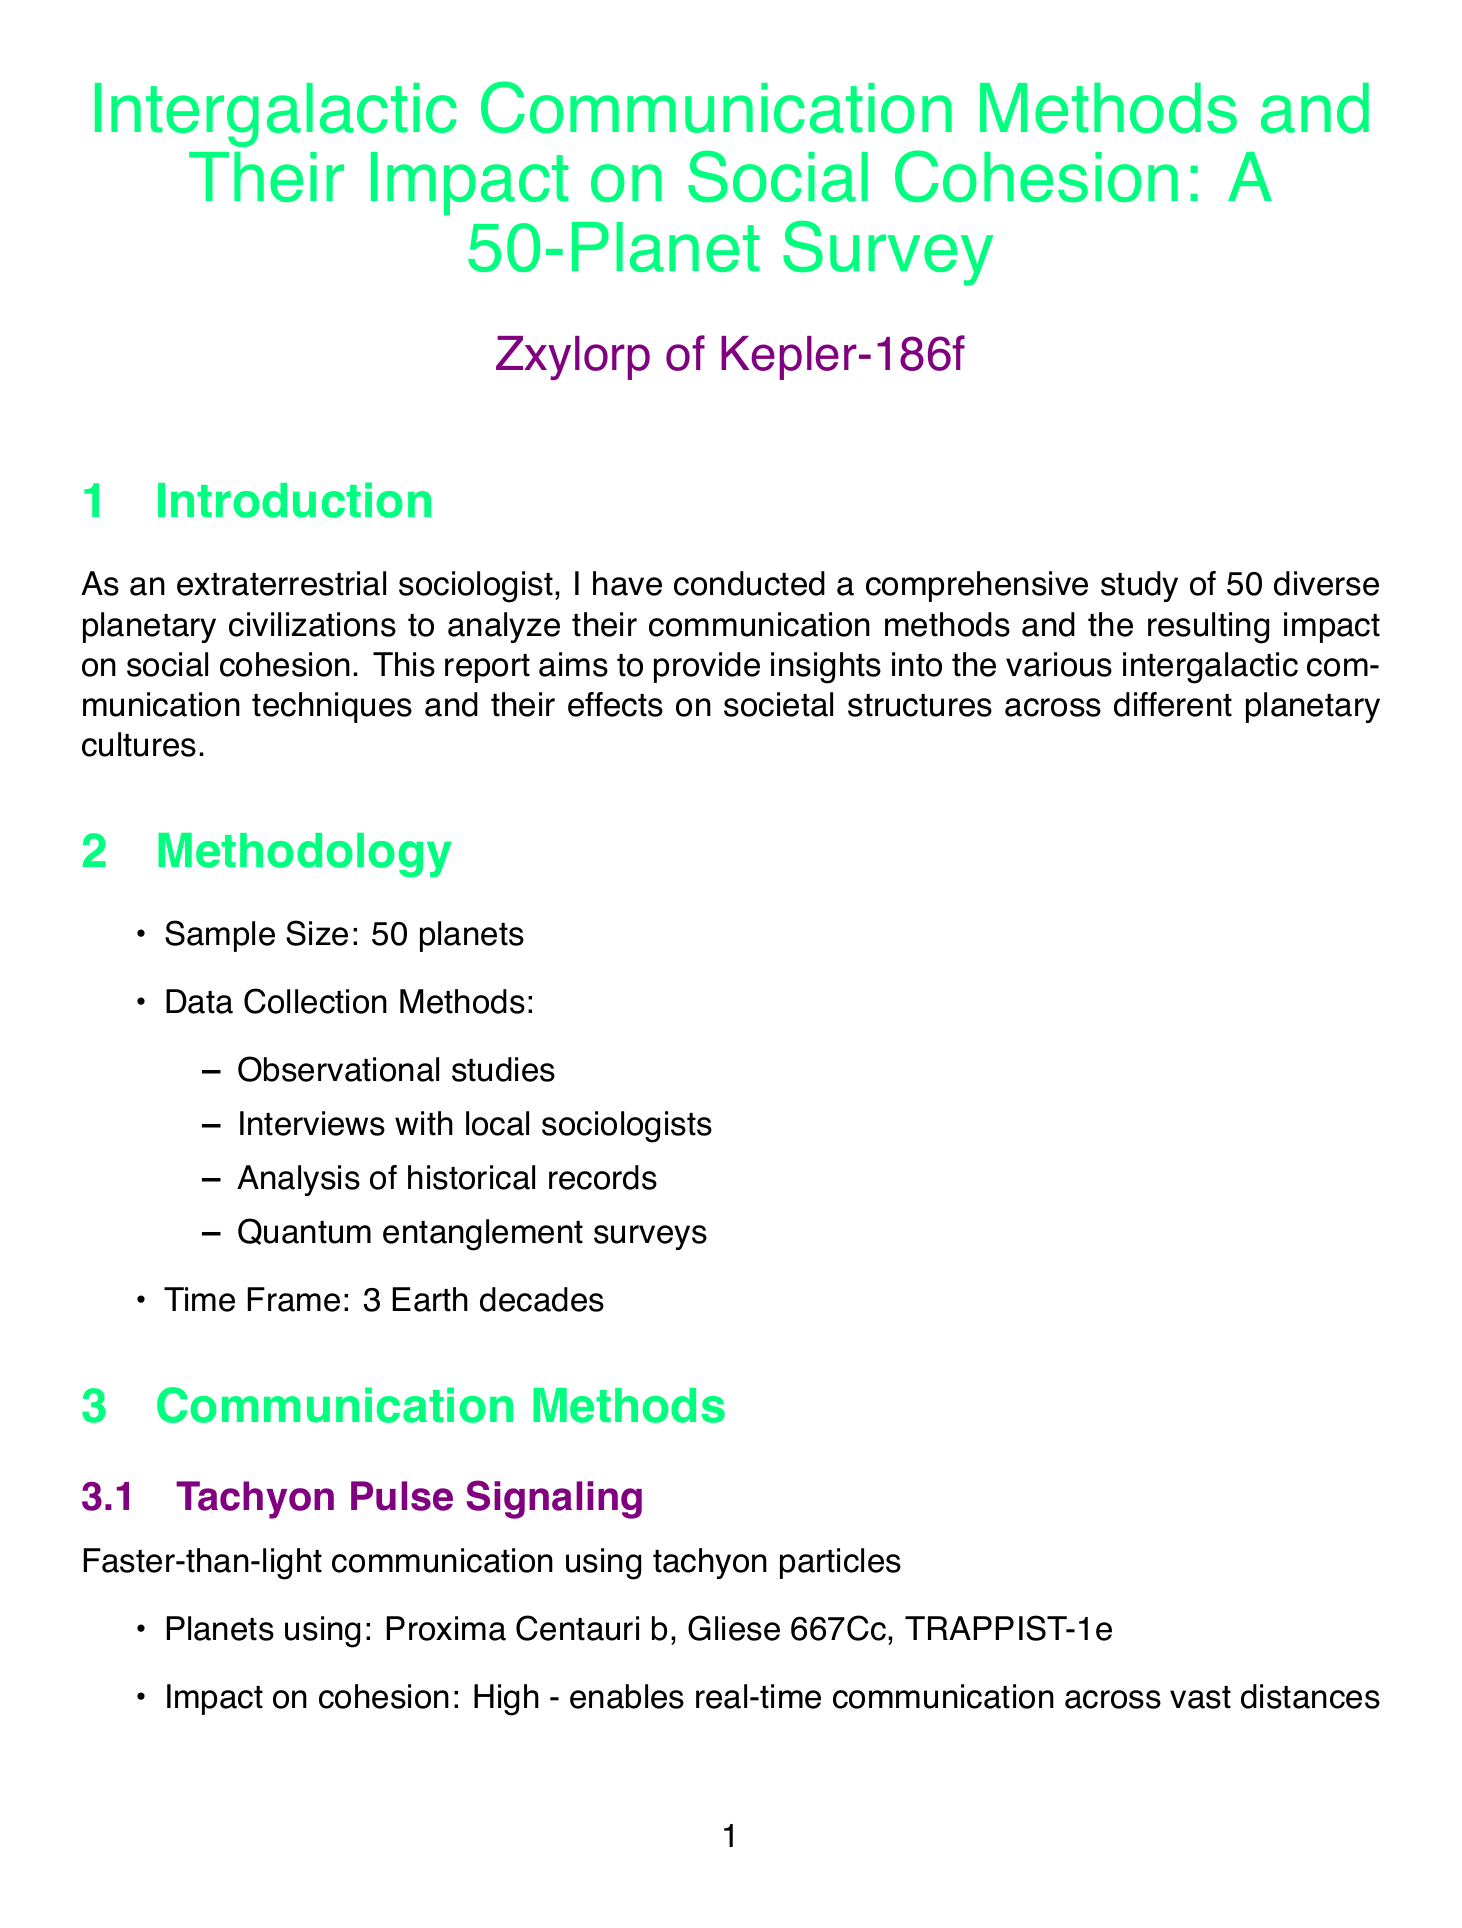what is the title of the report? The title is presented prominently at the beginning of the document.
Answer: Intergalactic Communication Methods and Their Impact on Social Cohesion: A 50-Planet Survey who is the author of the report? The author's name is provided in the author section of the document.
Answer: Zxylorp of Kepler-186f how many planets were included in the survey? The sample size is explicitly stated in the methodology section.
Answer: 50 which communication method is used by Proxima Centauri b? The planets using specific communication methods are listed in the communication methods section.
Answer: Tachyon Pulse Signaling what is the cohesion impact of Quantum Telepathy Networks? The impact on social cohesion is summarized in the description of each communication method.
Answer: Very high which social structure prefers Gravitational Wave Modulation? The communication preference for each social structure is detailed in the social structures section.
Answer: Distributed Democracies what is the cohesion level of Hive Mind Collectives? The cohesion level for each type of social structure is stated in the social structures section.
Answer: Extremely high which communication method is linked with Caste-based Hierarchies? The communication methods used by each social structure are specified in the document.
Answer: Bioluminescent Sign Language what recommendation is proposed for communication technologies? The recommendations section includes suggestions aimed at improving intergalactic communication.
Answer: Encourage the development of quantum communication technologies for improved intergalactic understanding 